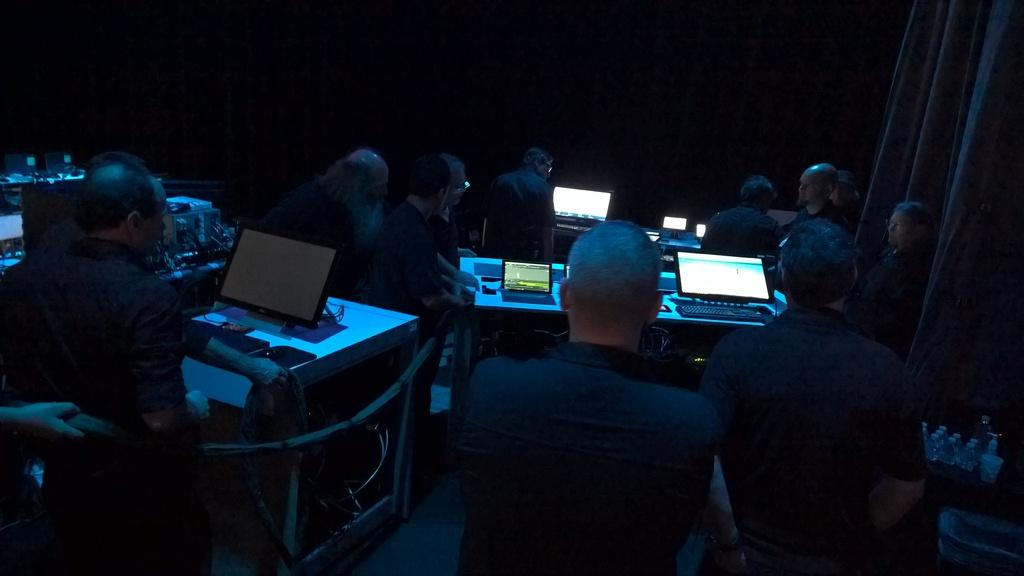What are the people in the image doing? The people in the image are sitting. What objects are on the tables in the image? There are laptops on the tables in the image. What type of window treatment is visible in the image? There are curtains at the right back of the image. How would you describe the lighting in the image? The background of the image is dark. How much dirt can be seen on the floor in the image? There is no dirt visible on the floor in the image. 